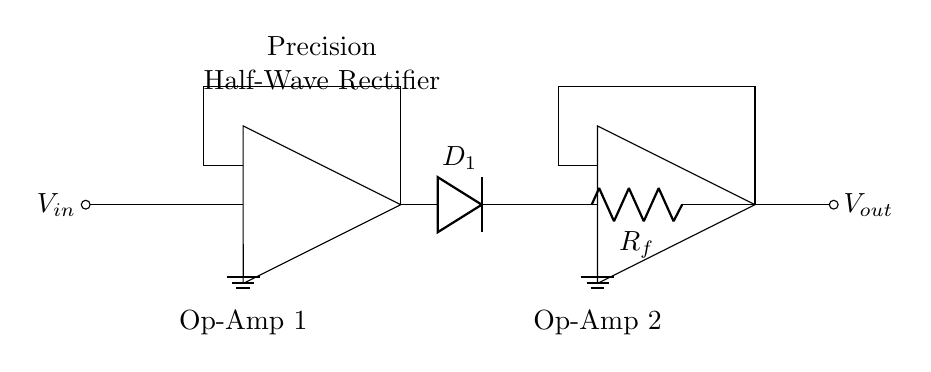What is the type of rectifier shown in this circuit? The circuit is a precision half-wave rectifier, which processes only the positive half of the input signal.
Answer: precision half-wave rectifier How many operational amplifiers are used in this circuit? There are two operational amplifiers present in the circuit, indicated by the two distinct op-amp symbols labeled as Op-Amp 1 and Op-Amp 2.
Answer: two What is the purpose of the diode in this circuit? The diode conducts only in one direction, allowing the positive half of the input signal to pass through while blocking the negative half, thus achieving rectification.
Answer: rectification What component is used for feedback in the output stage? The feedback resistor, labeled as R_f, is used to stabilize the gain and feedback in the output stage of the second operational amplifier.
Answer: R_f What happens to the output voltage when the input voltage is negative? When the input voltage is negative, the diode blocks the signal, resulting in zero output voltage.
Answer: zero What is the role of Op-Amp 1 in this circuit? Op-Amp 1 is responsible for amplifying the input signal before it is rectified by the diode, effectively increasing the gain for the positive half of the waveform.
Answer: amplifying input signal How does this circuit ensure accuracy in processing the input signal? The use of operational amplifiers allows for precise control over the gain and characteristics of the rectified output, minimizing errors in signal processing.
Answer: precise control 